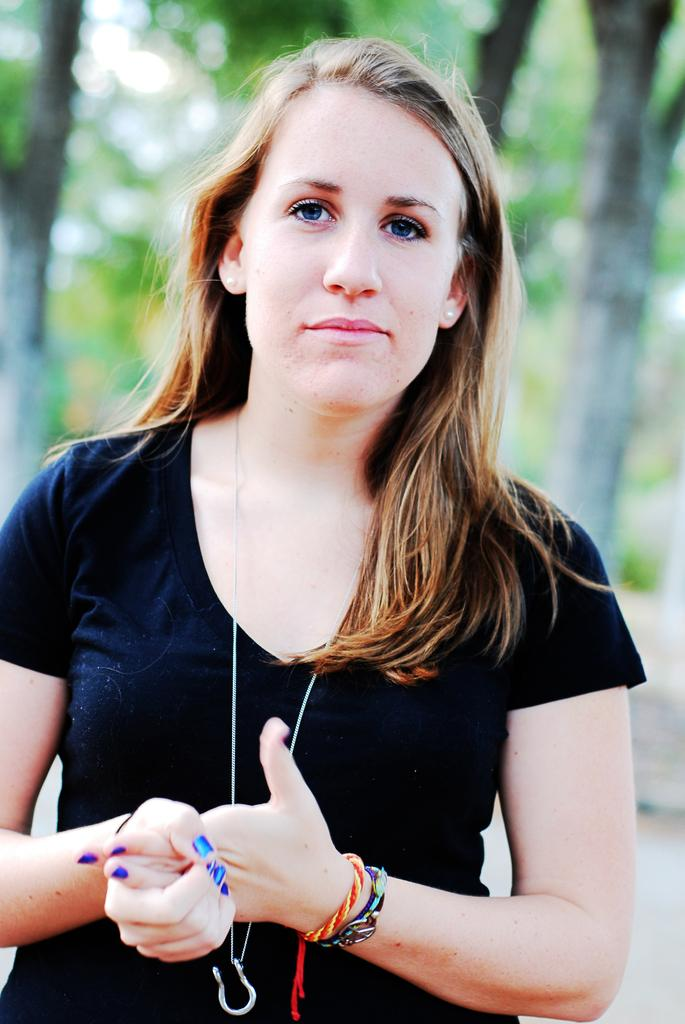Who is present in the image? There is a lady in the image. What is the lady doing in the image? The lady is standing on the road. What can be seen in the background of the image? There are trees visible in the image. How many girls are present in the image? There is no mention of girls in the image; it only features a lady. 